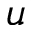Convert formula to latex. <formula><loc_0><loc_0><loc_500><loc_500>u</formula> 